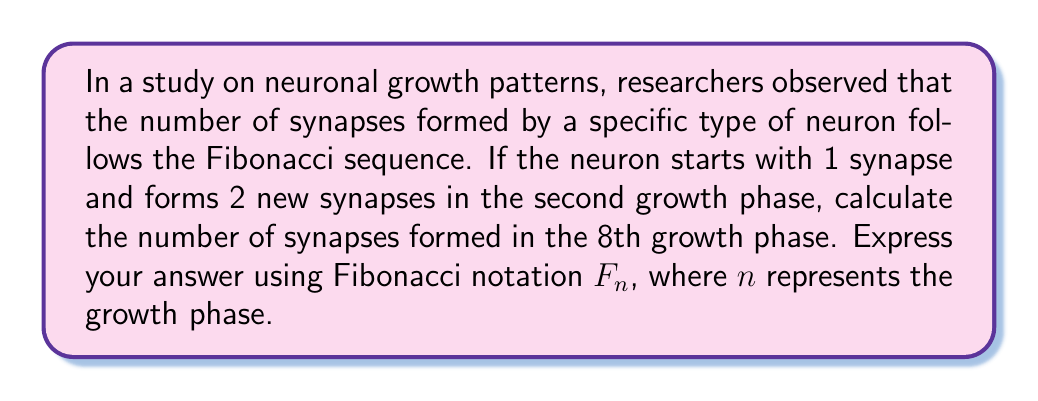Show me your answer to this math problem. To solve this problem, let's follow these steps:

1) Recall that the Fibonacci sequence is defined as:
   $F_n = F_{n-1} + F_{n-2}$ for $n > 2$
   with initial conditions $F_1 = 1$ and $F_2 = 2$

2) Let's calculate the first 8 terms of the sequence:
   $F_1 = 1$ (given)
   $F_2 = 2$ (given)
   $F_3 = F_2 + F_1 = 2 + 1 = 3$
   $F_4 = F_3 + F_2 = 3 + 2 = 5$
   $F_5 = F_4 + F_3 = 5 + 3 = 8$
   $F_6 = F_5 + F_4 = 8 + 5 = 13$
   $F_7 = F_6 + F_5 = 13 + 8 = 21$
   $F_8 = F_7 + F_6 = 21 + 13 = 34$

3) The question asks for the number of synapses formed in the 8th growth phase, which corresponds to $F_8$ in our sequence.

4) Therefore, the number of synapses formed in the 8th growth phase is 34, or $F_8$ in Fibonacci notation.
Answer: $F_8$ 